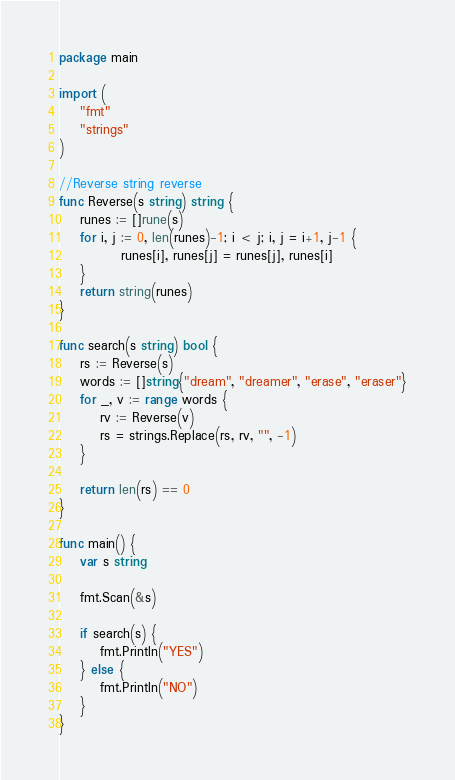<code> <loc_0><loc_0><loc_500><loc_500><_Go_>package main

import (
	"fmt"
	"strings"
)

//Reverse string reverse
func Reverse(s string) string {
	runes := []rune(s)
	for i, j := 0, len(runes)-1; i < j; i, j = i+1, j-1 {
			runes[i], runes[j] = runes[j], runes[i]
	}
	return string(runes)
}

func search(s string) bool {
	rs := Reverse(s)
	words := []string{"dream", "dreamer", "erase", "eraser"}
	for _, v := range words {
		rv := Reverse(v)
		rs = strings.Replace(rs, rv, "", -1)
	}

	return len(rs) == 0
}

func main() {
	var s string
	
	fmt.Scan(&s)

	if search(s) {
		fmt.Println("YES")
	} else {
		fmt.Println("NO")
	}
}</code> 